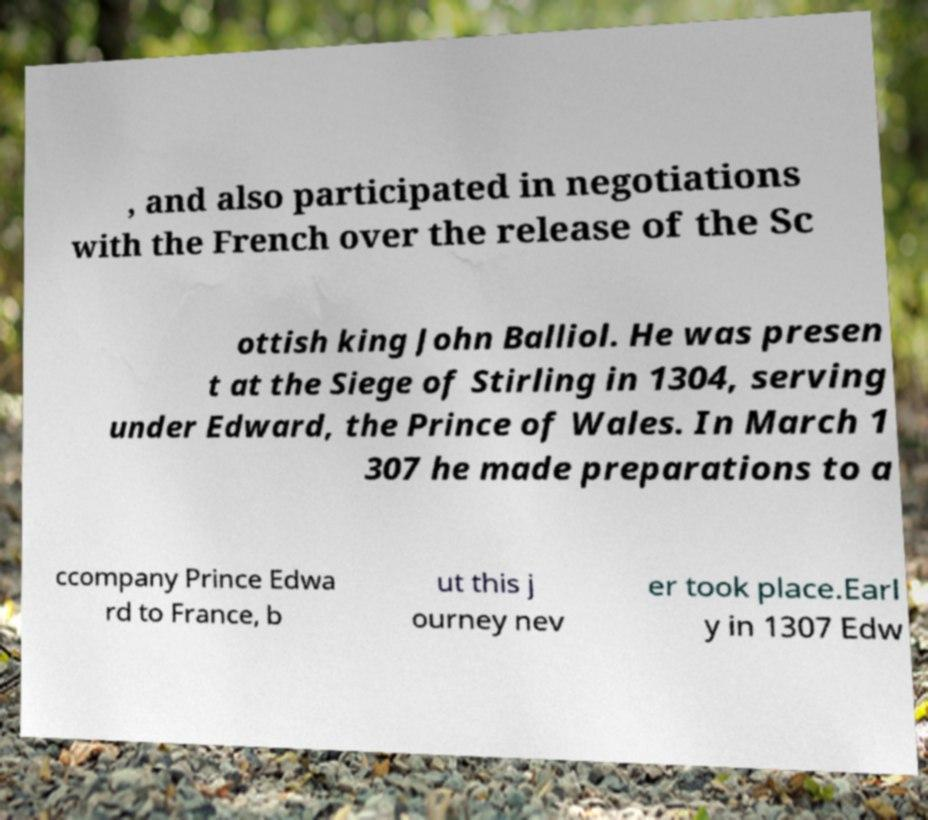Could you assist in decoding the text presented in this image and type it out clearly? , and also participated in negotiations with the French over the release of the Sc ottish king John Balliol. He was presen t at the Siege of Stirling in 1304, serving under Edward, the Prince of Wales. In March 1 307 he made preparations to a ccompany Prince Edwa rd to France, b ut this j ourney nev er took place.Earl y in 1307 Edw 